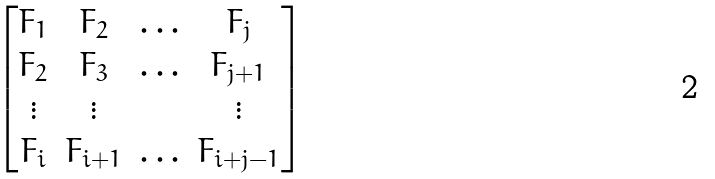Convert formula to latex. <formula><loc_0><loc_0><loc_500><loc_500>\begin{bmatrix} F _ { 1 } & F _ { 2 } & \hdots & F _ { j } \\ F _ { 2 } & F _ { 3 } & \hdots & F _ { j + 1 } \\ \vdots & \vdots & & \vdots \\ F _ { i } & F _ { i + 1 } & \hdots & F _ { i + j - 1 } \end{bmatrix}</formula> 